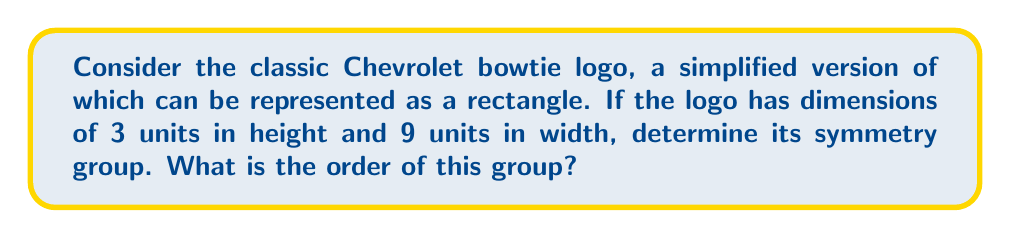Teach me how to tackle this problem. To determine the symmetry group of the Chevrolet bowtie logo, we need to consider all the symmetry operations that leave the logo unchanged. Let's approach this step-by-step:

1) The symmetries of a rectangle include:
   - Identity (E): No change
   - 180° rotation (C2): Rotation around the center
   - Horizontal reflection (H): Reflection across the horizontal axis
   - Vertical reflection (V): Reflection across the vertical axis

2) These symmetries form a group under composition. This group is known as the dihedral group D2, also called the Klein four-group.

3) To verify this, let's check the group properties:
   - Closure: Composing any two symmetries results in another symmetry in the set.
   - Associativity: This is inherent in geometric transformations.
   - Identity: The identity transformation E is included.
   - Inverse: Each symmetry is its own inverse (E² = C2² = H² = V² = E).

4) The group table for D2 is:

   $$\begin{array}{c|cccc}
      & E & C2 & H & V \\
   \hline
   E  & E & C2 & H & V \\
   C2 & C2 & E & V & H \\
   H  & H & V & E & C2 \\
   V  & V & H & C2 & E
   \end{array}$$

5) The order of a group is the number of elements in the group. In this case, there are 4 elements: E, C2, H, and V.

Therefore, the symmetry group of the Chevrolet bowtie logo is the dihedral group D2, which is isomorphic to the Klein four-group V4.
Answer: The symmetry group of the Chevrolet bowtie logo is D2 (or V4), and its order is 4. 